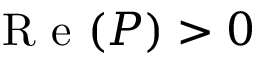Convert formula to latex. <formula><loc_0><loc_0><loc_500><loc_500>R e ( P ) > 0</formula> 